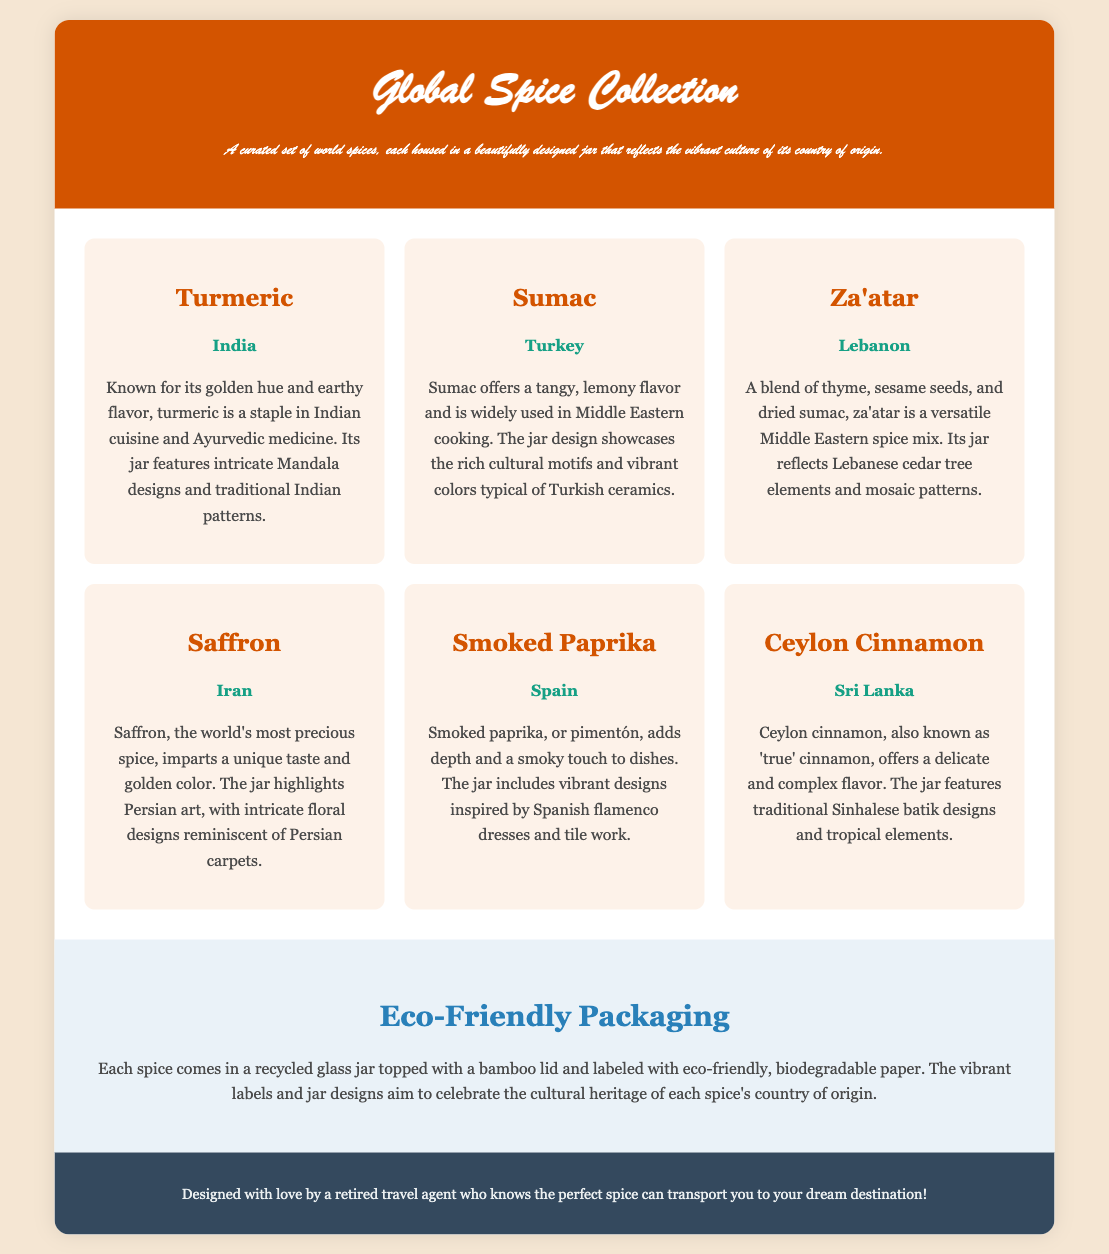What spices are included in the collection? The document lists six spices: Turmeric, Sumac, Za'atar, Saffron, Smoked Paprika, and Ceylon Cinnamon.
Answer: Turmeric, Sumac, Za'atar, Saffron, Smoked Paprika, Ceylon Cinnamon Which country is associated with Saffron? According to the spice jar description in the document, Saffron is associated with Iran.
Answer: Iran What type of packaging is used for the spices? The description in the document states that each spice comes in a recycled glass jar with a bamboo lid and biodegradable paper label.
Answer: Eco-Friendly Packaging What design elements are featured on the Ceylon Cinnamon jar? The document mentions that the Ceylon Cinnamon jar features traditional Sinhalese batik designs and tropical elements.
Answer: Traditional Sinhalese batik designs, tropical elements How does the jar design for Sumac reflect Turkish culture? The document indicates that the Sumac jar design showcases rich cultural motifs and vibrant colors typical of Turkish ceramics.
Answer: Rich cultural motifs, vibrant colors Who created the Global Spice Collection? The footer of the document mentions that it was designed by a retired travel agent.
Answer: A retired travel agent 